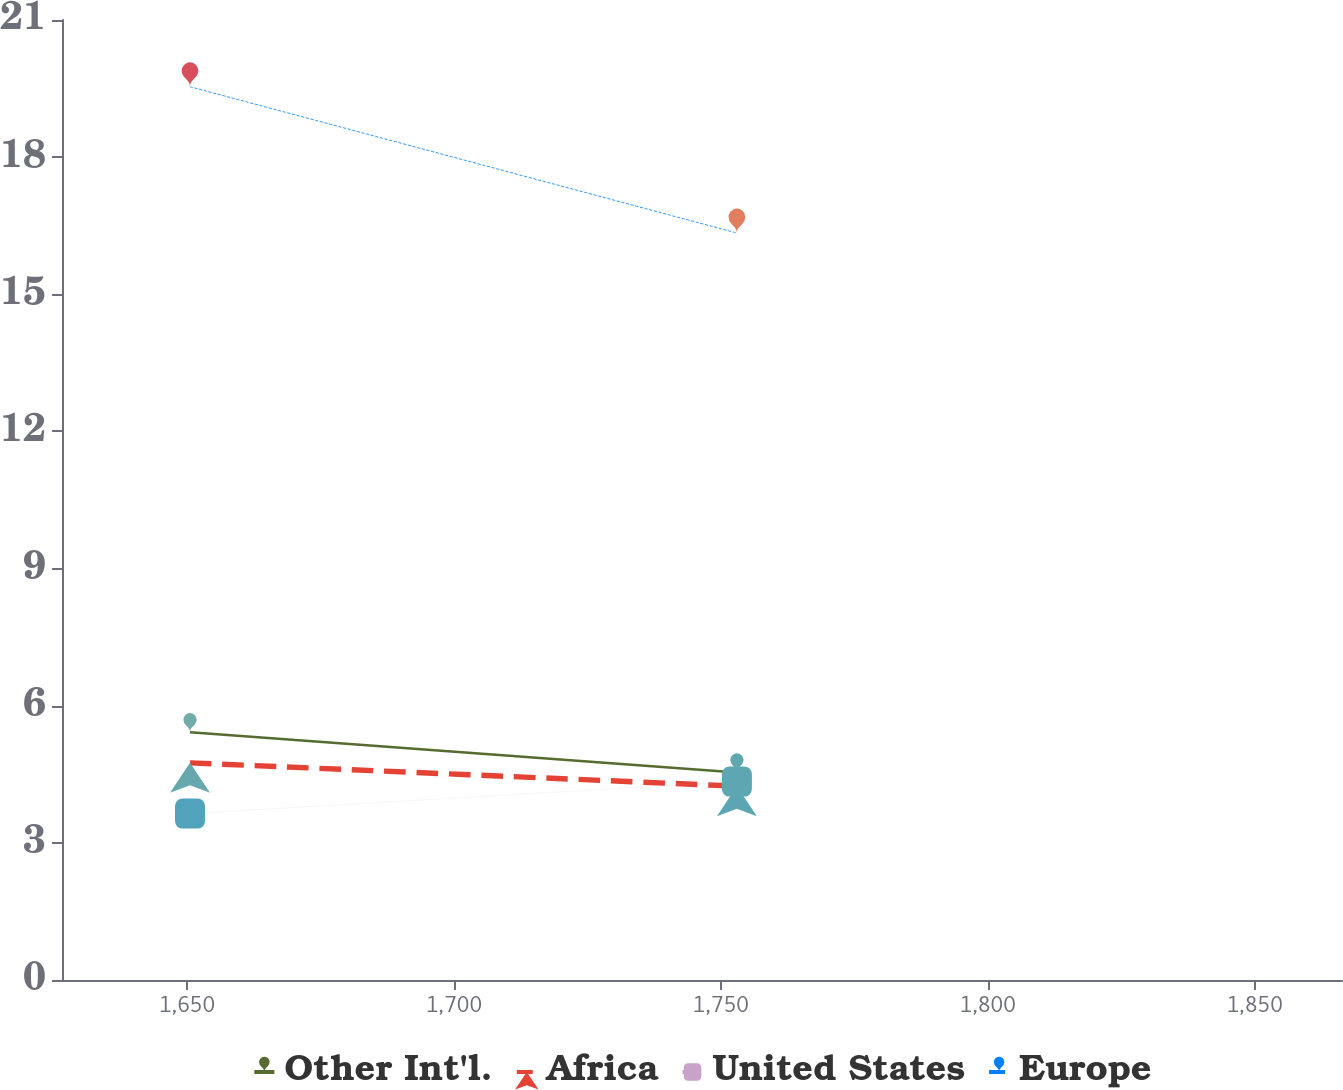Convert chart. <chart><loc_0><loc_0><loc_500><loc_500><line_chart><ecel><fcel>Other Int'l.<fcel>Africa<fcel>United States<fcel>Europe<nl><fcel>1650.57<fcel>5.42<fcel>4.75<fcel>3.64<fcel>19.54<nl><fcel>1753.02<fcel>4.54<fcel>4.24<fcel>4.34<fcel>16.34<nl><fcel>1890.35<fcel>4.63<fcel>4.17<fcel>3.96<fcel>15.99<nl></chart> 